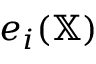<formula> <loc_0><loc_0><loc_500><loc_500>e _ { i } ( \mathbb { X } )</formula> 